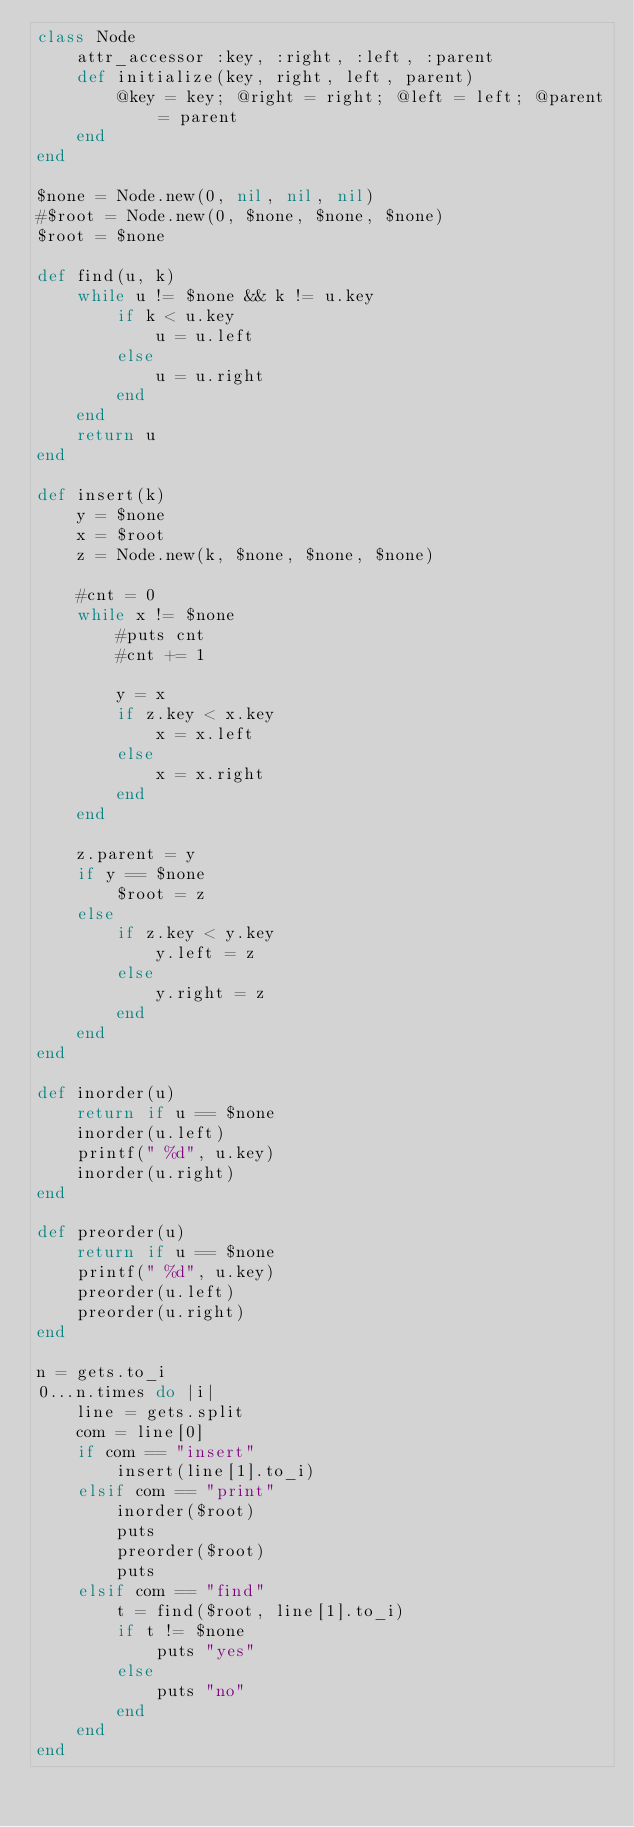Convert code to text. <code><loc_0><loc_0><loc_500><loc_500><_Ruby_>class Node
	attr_accessor :key, :right, :left, :parent
	def initialize(key, right, left, parent)
		@key = key; @right = right; @left = left; @parent = parent
	end
end

$none = Node.new(0, nil, nil, nil)
#$root = Node.new(0, $none, $none, $none)
$root = $none

def find(u, k)
	while u != $none && k != u.key
		if k < u.key
			u = u.left
		else
			u = u.right
		end
	end
	return u
end

def insert(k)
	y = $none	
	x = $root
	z = Node.new(k, $none, $none, $none)

	#cnt = 0
	while x != $none
		#puts cnt
		#cnt += 1

		y = x
		if z.key < x.key
			x = x.left
		else
			x = x.right
		end
	end

	z.parent = y
	if y == $none
		$root = z
	else
		if z.key < y.key
			y.left = z
		else
			y.right = z
		end
	end
end

def inorder(u)
	return if u == $none
	inorder(u.left)
	printf(" %d", u.key)
	inorder(u.right)
end

def preorder(u)
	return if u == $none
	printf(" %d", u.key)
	preorder(u.left)
	preorder(u.right)
end

n = gets.to_i
0...n.times do |i|
	line = gets.split
	com = line[0]
	if com == "insert"
		insert(line[1].to_i)
	elsif com == "print"
		inorder($root)
		puts
		preorder($root)
		puts
	elsif com == "find"
		t = find($root, line[1].to_i)
		if t != $none
			puts "yes"
		else
			puts "no"
		end
	end
end</code> 